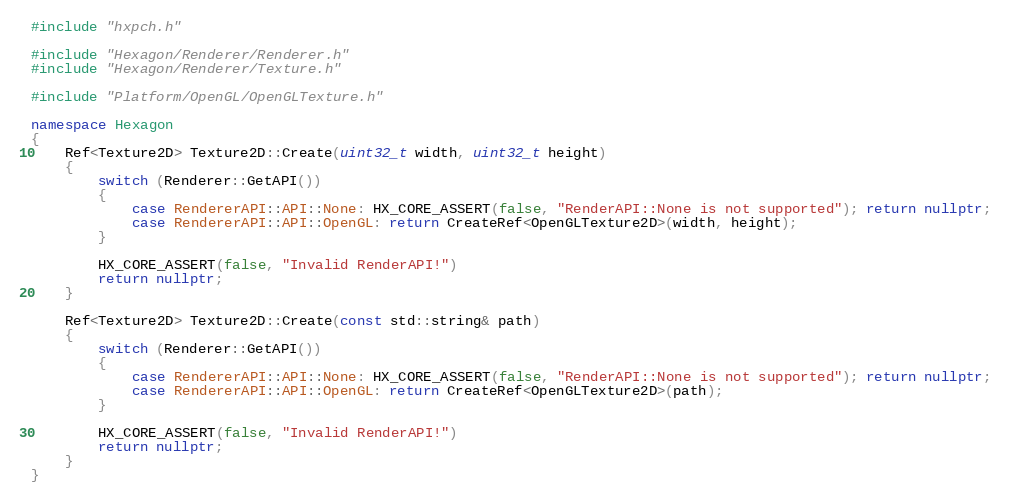Convert code to text. <code><loc_0><loc_0><loc_500><loc_500><_C++_>#include "hxpch.h"

#include "Hexagon/Renderer/Renderer.h"
#include "Hexagon/Renderer/Texture.h"

#include "Platform/OpenGL/OpenGLTexture.h"

namespace Hexagon
{
	Ref<Texture2D> Texture2D::Create(uint32_t width, uint32_t height)
	{
		switch (Renderer::GetAPI())
		{
			case RendererAPI::API::None: HX_CORE_ASSERT(false, "RenderAPI::None is not supported"); return nullptr;
			case RendererAPI::API::OpenGL: return CreateRef<OpenGLTexture2D>(width, height);
		}

		HX_CORE_ASSERT(false, "Invalid RenderAPI!")
		return nullptr;
	}

	Ref<Texture2D> Texture2D::Create(const std::string& path) 
	{
		switch (Renderer::GetAPI())
		{
			case RendererAPI::API::None: HX_CORE_ASSERT(false, "RenderAPI::None is not supported"); return nullptr;
			case RendererAPI::API::OpenGL: return CreateRef<OpenGLTexture2D>(path);
		}

		HX_CORE_ASSERT(false, "Invalid RenderAPI!")
		return nullptr;
	}
}</code> 